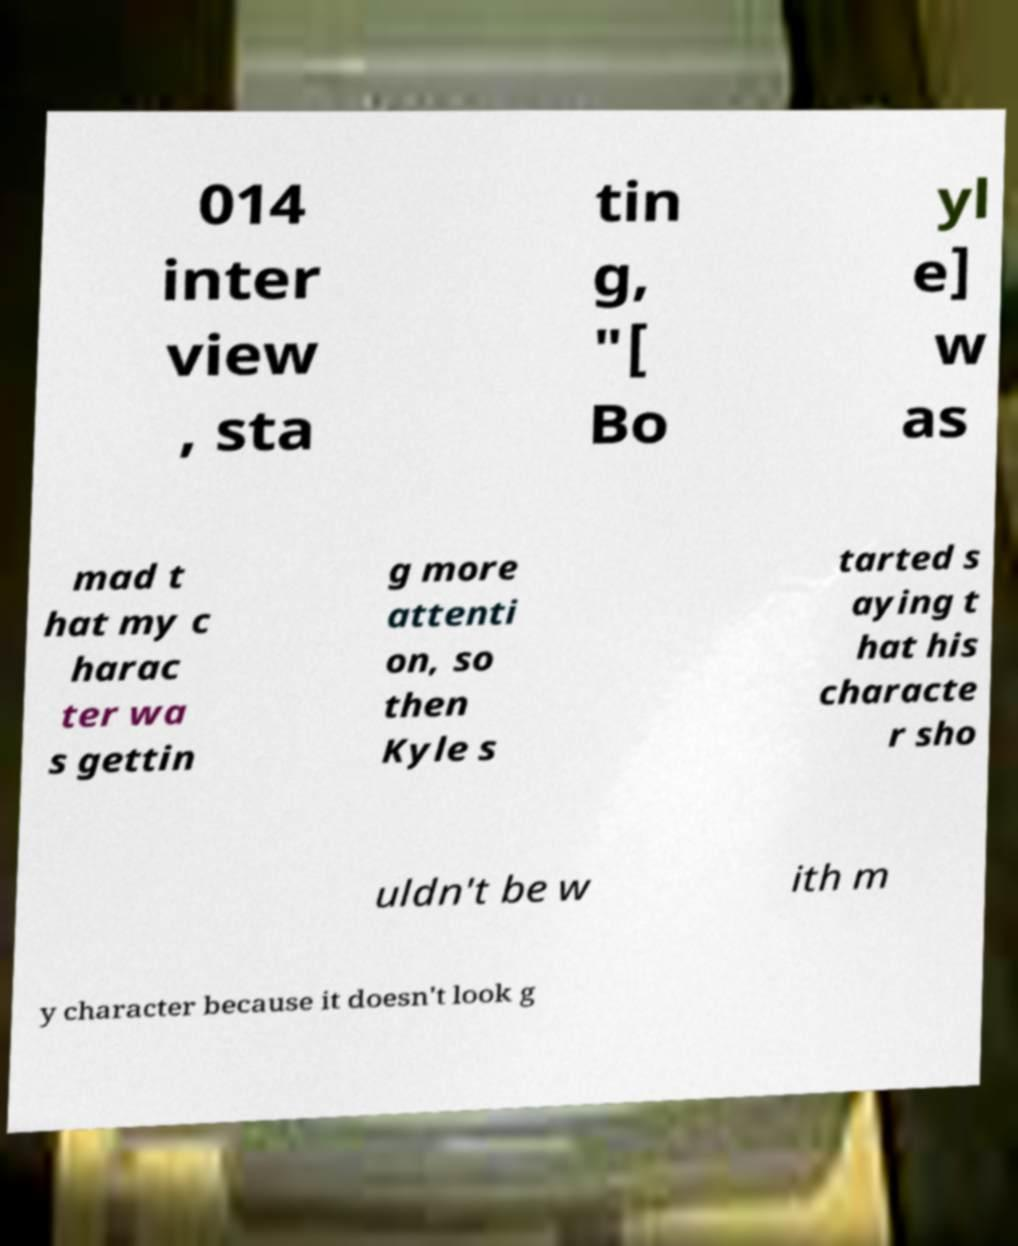Please identify and transcribe the text found in this image. 014 inter view , sta tin g, "[ Bo yl e] w as mad t hat my c harac ter wa s gettin g more attenti on, so then Kyle s tarted s aying t hat his characte r sho uldn't be w ith m y character because it doesn't look g 